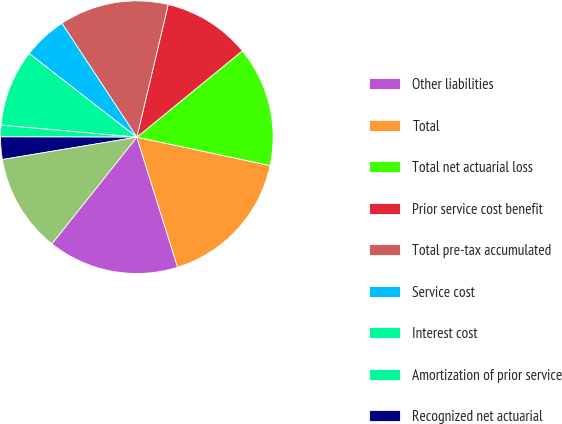Convert chart to OTSL. <chart><loc_0><loc_0><loc_500><loc_500><pie_chart><fcel>Other liabilities<fcel>Total<fcel>Total net actuarial loss<fcel>Prior service cost benefit<fcel>Total pre-tax accumulated<fcel>Service cost<fcel>Interest cost<fcel>Amortization of prior service<fcel>Recognized net actuarial<fcel>Net periodic benefit cost<nl><fcel>15.54%<fcel>16.83%<fcel>14.25%<fcel>10.39%<fcel>12.96%<fcel>5.23%<fcel>9.1%<fcel>1.37%<fcel>2.66%<fcel>11.67%<nl></chart> 